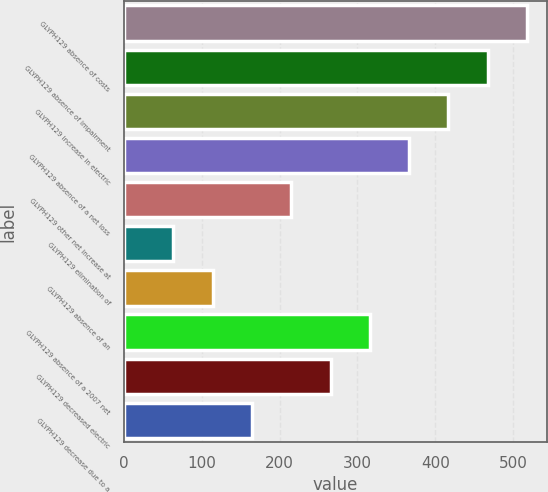<chart> <loc_0><loc_0><loc_500><loc_500><bar_chart><fcel>GLYPH129 absence of costs<fcel>GLYPH129 absence of impairment<fcel>GLYPH129 increase in electric<fcel>GLYPH129 absence of a net loss<fcel>GLYPH129 other net increase at<fcel>GLYPH129 elimination of<fcel>GLYPH129 absence of an<fcel>GLYPH129 absence of a 2007 net<fcel>GLYPH129 decreased electric<fcel>GLYPH129 decrease due to a<nl><fcel>518<fcel>467.5<fcel>417<fcel>366.5<fcel>215<fcel>63.5<fcel>114<fcel>316<fcel>265.5<fcel>164.5<nl></chart> 